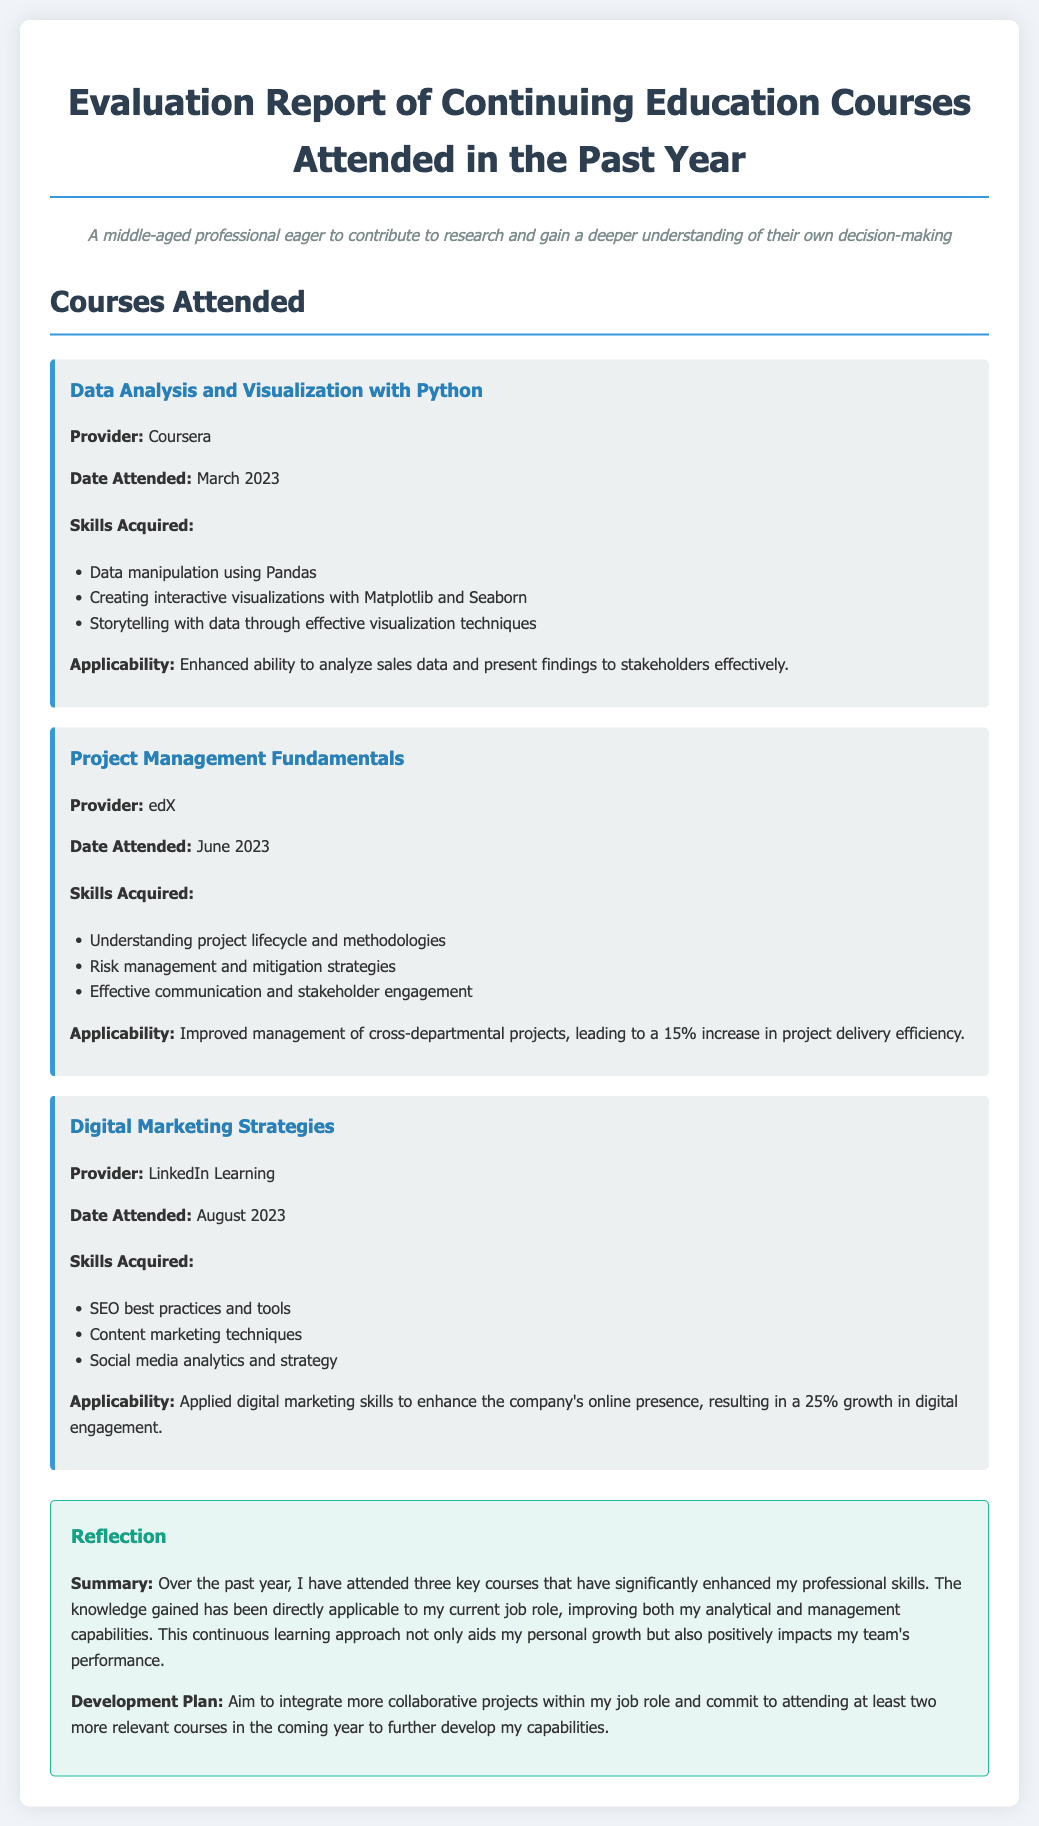What is the title of the report? The title of the report is displayed prominently at the top of the document, indicating the focus on evaluation of courses.
Answer: Evaluation Report of Continuing Education Courses How many courses are listed in the report? The report contains a section detailing the courses attended, specifically counting the number of courses listed.
Answer: 3 What is the date attended for the Digital Marketing Strategies course? Each course entry includes the specific date attended, providing a clear timeline for when the courses were completed.
Answer: August 2023 What skill was acquired from the Data Analysis and Visualization with Python course? The report lists specific skills acquired for each course to highlight the educational benefits.
Answer: Data manipulation using Pandas What percentage increase in project delivery efficiency resulted from attending the Project Management Fundamentals course? This figure illustrates the impact of the course on the individual's professional performance and is noted in the applicability section.
Answer: 15% What is the main focus of the reflection section? The reflection section summarizes the overall impact of the courses on professional development and sets future learning goals.
Answer: Summary of courses and development plan Which provider offered the Project Management Fundamentals course? The provider information for each course is included to indicate the source of the education received.
Answer: edX What is the main goal outlined in the Development Plan? The development plan expresses the individual's intention for continued professional growth through further education.
Answer: Integrate more collaborative projects 